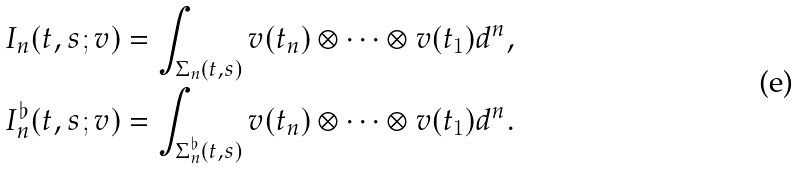Convert formula to latex. <formula><loc_0><loc_0><loc_500><loc_500>I _ { n } ( t , s ; v ) & = \int _ { \Sigma _ { n } ( t , s ) } v ( t _ { n } ) \otimes \dots \otimes v ( t _ { 1 } ) d \L ^ { n } , \\ I _ { n } ^ { \flat } ( t , s ; v ) & = \int _ { \Sigma _ { n } ^ { \flat } ( t , s ) } v ( t _ { n } ) \otimes \dots \otimes v ( t _ { 1 } ) d \L ^ { n } .</formula> 